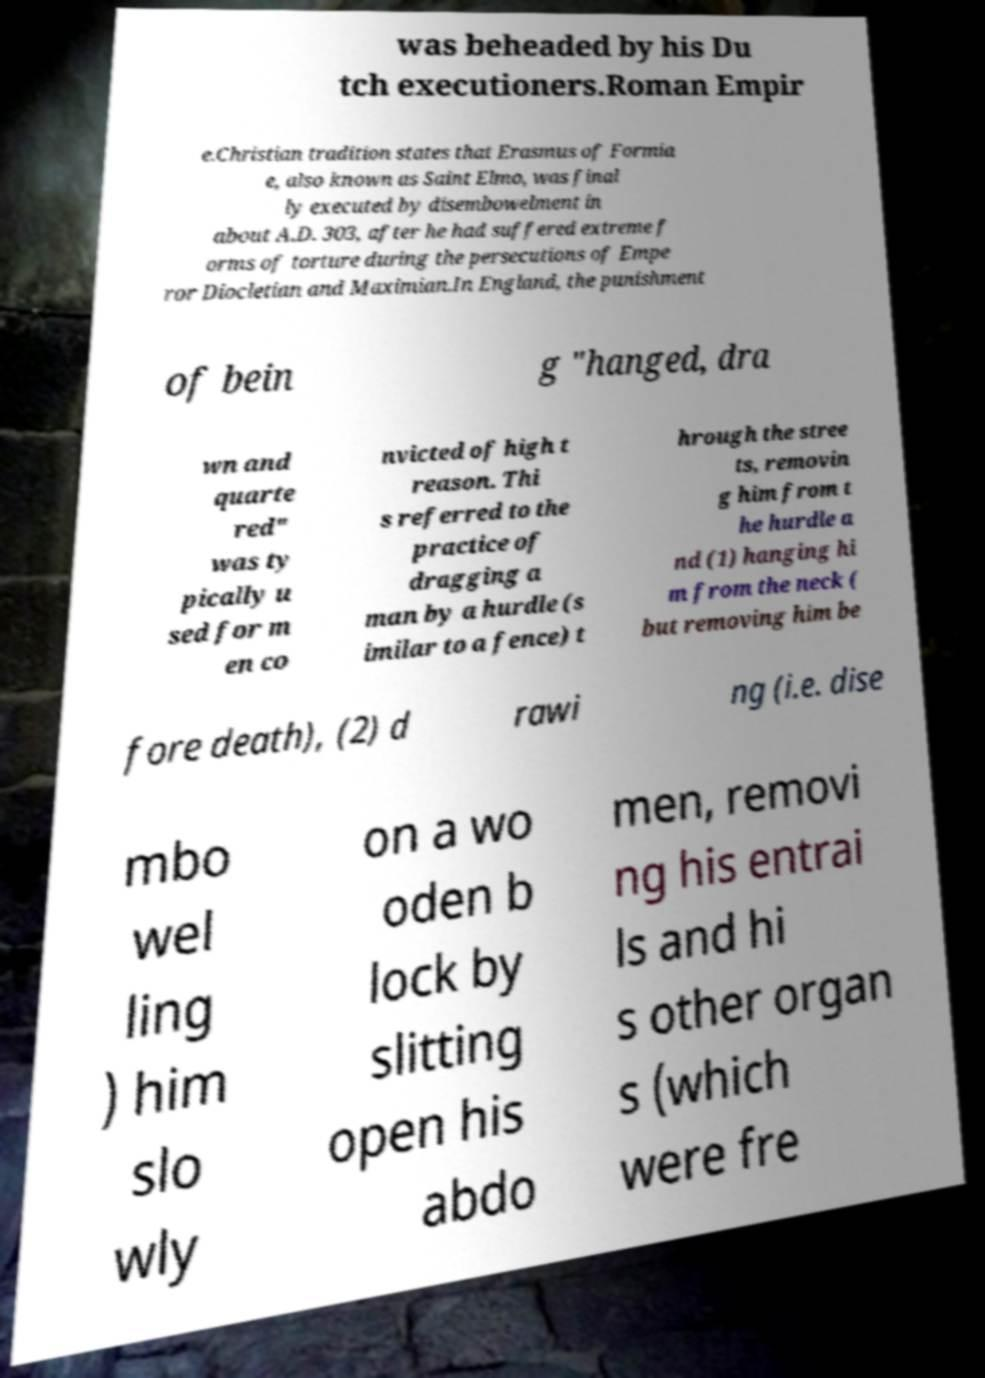For documentation purposes, I need the text within this image transcribed. Could you provide that? was beheaded by his Du tch executioners.Roman Empir e.Christian tradition states that Erasmus of Formia e, also known as Saint Elmo, was final ly executed by disembowelment in about A.D. 303, after he had suffered extreme f orms of torture during the persecutions of Empe ror Diocletian and Maximian.In England, the punishment of bein g "hanged, dra wn and quarte red" was ty pically u sed for m en co nvicted of high t reason. Thi s referred to the practice of dragging a man by a hurdle (s imilar to a fence) t hrough the stree ts, removin g him from t he hurdle a nd (1) hanging hi m from the neck ( but removing him be fore death), (2) d rawi ng (i.e. dise mbo wel ling ) him slo wly on a wo oden b lock by slitting open his abdo men, removi ng his entrai ls and hi s other organ s (which were fre 